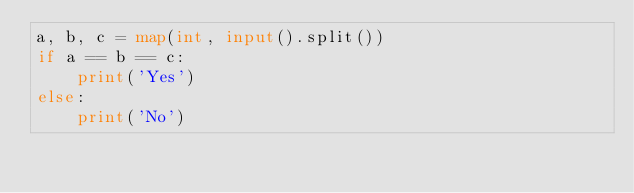Convert code to text. <code><loc_0><loc_0><loc_500><loc_500><_Python_>a, b, c = map(int, input().split())
if a == b == c:
    print('Yes')
else:
    print('No')</code> 